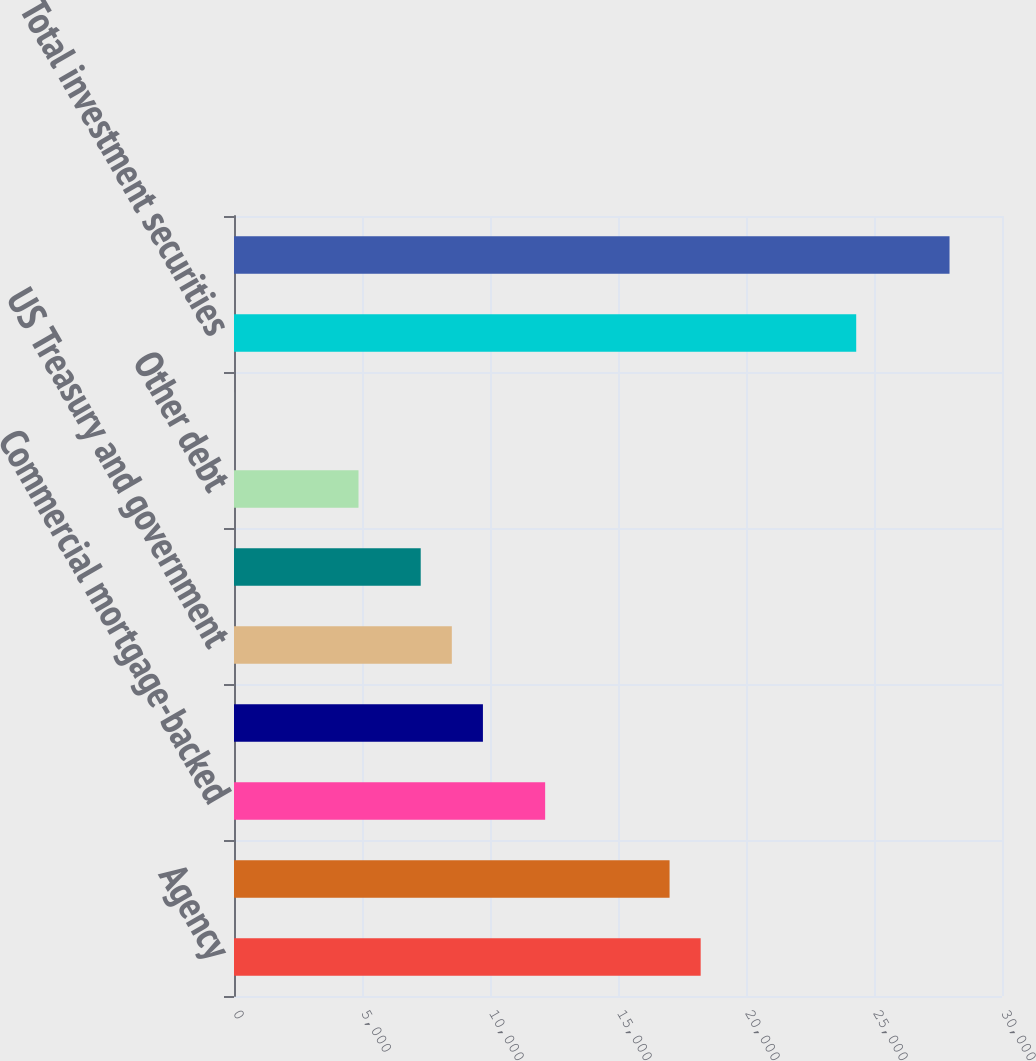Convert chart to OTSL. <chart><loc_0><loc_0><loc_500><loc_500><bar_chart><fcel>Agency<fcel>Non-agency<fcel>Commercial mortgage-backed<fcel>Asset-backed<fcel>US Treasury and government<fcel>State and municipal<fcel>Other debt<fcel>Corporate stocks and other<fcel>Total investment securities<fcel>Commercial<nl><fcel>18229.5<fcel>17014.4<fcel>12154<fcel>9723.8<fcel>8508.7<fcel>7293.6<fcel>4863.4<fcel>3<fcel>24305<fcel>27950.3<nl></chart> 